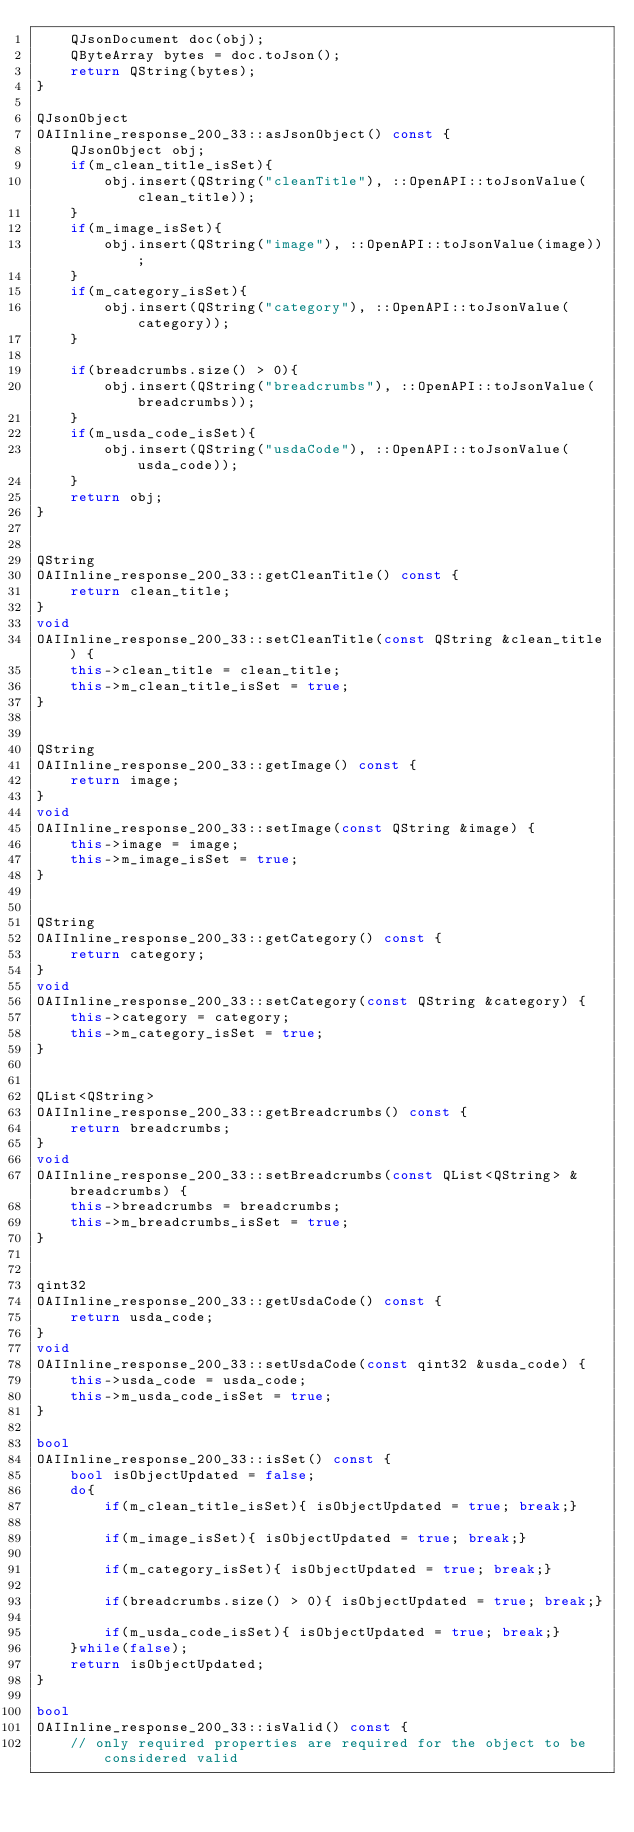Convert code to text. <code><loc_0><loc_0><loc_500><loc_500><_C++_>    QJsonDocument doc(obj);
    QByteArray bytes = doc.toJson();
    return QString(bytes);
}

QJsonObject
OAIInline_response_200_33::asJsonObject() const {
    QJsonObject obj;
	if(m_clean_title_isSet){
        obj.insert(QString("cleanTitle"), ::OpenAPI::toJsonValue(clean_title));
    }
	if(m_image_isSet){
        obj.insert(QString("image"), ::OpenAPI::toJsonValue(image));
    }
	if(m_category_isSet){
        obj.insert(QString("category"), ::OpenAPI::toJsonValue(category));
    }
	
    if(breadcrumbs.size() > 0){
        obj.insert(QString("breadcrumbs"), ::OpenAPI::toJsonValue(breadcrumbs));
    } 
	if(m_usda_code_isSet){
        obj.insert(QString("usdaCode"), ::OpenAPI::toJsonValue(usda_code));
    }
    return obj;
}


QString
OAIInline_response_200_33::getCleanTitle() const {
    return clean_title;
}
void
OAIInline_response_200_33::setCleanTitle(const QString &clean_title) {
    this->clean_title = clean_title;
    this->m_clean_title_isSet = true;
}


QString
OAIInline_response_200_33::getImage() const {
    return image;
}
void
OAIInline_response_200_33::setImage(const QString &image) {
    this->image = image;
    this->m_image_isSet = true;
}


QString
OAIInline_response_200_33::getCategory() const {
    return category;
}
void
OAIInline_response_200_33::setCategory(const QString &category) {
    this->category = category;
    this->m_category_isSet = true;
}


QList<QString>
OAIInline_response_200_33::getBreadcrumbs() const {
    return breadcrumbs;
}
void
OAIInline_response_200_33::setBreadcrumbs(const QList<QString> &breadcrumbs) {
    this->breadcrumbs = breadcrumbs;
    this->m_breadcrumbs_isSet = true;
}


qint32
OAIInline_response_200_33::getUsdaCode() const {
    return usda_code;
}
void
OAIInline_response_200_33::setUsdaCode(const qint32 &usda_code) {
    this->usda_code = usda_code;
    this->m_usda_code_isSet = true;
}

bool
OAIInline_response_200_33::isSet() const {
    bool isObjectUpdated = false;
    do{ 
        if(m_clean_title_isSet){ isObjectUpdated = true; break;}
    
        if(m_image_isSet){ isObjectUpdated = true; break;}
    
        if(m_category_isSet){ isObjectUpdated = true; break;}
    
        if(breadcrumbs.size() > 0){ isObjectUpdated = true; break;}
    
        if(m_usda_code_isSet){ isObjectUpdated = true; break;}
    }while(false);
    return isObjectUpdated;
}

bool
OAIInline_response_200_33::isValid() const {
    // only required properties are required for the object to be considered valid</code> 